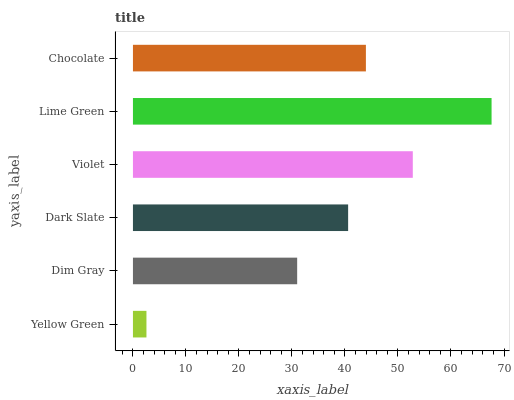Is Yellow Green the minimum?
Answer yes or no. Yes. Is Lime Green the maximum?
Answer yes or no. Yes. Is Dim Gray the minimum?
Answer yes or no. No. Is Dim Gray the maximum?
Answer yes or no. No. Is Dim Gray greater than Yellow Green?
Answer yes or no. Yes. Is Yellow Green less than Dim Gray?
Answer yes or no. Yes. Is Yellow Green greater than Dim Gray?
Answer yes or no. No. Is Dim Gray less than Yellow Green?
Answer yes or no. No. Is Chocolate the high median?
Answer yes or no. Yes. Is Dark Slate the low median?
Answer yes or no. Yes. Is Dim Gray the high median?
Answer yes or no. No. Is Chocolate the low median?
Answer yes or no. No. 